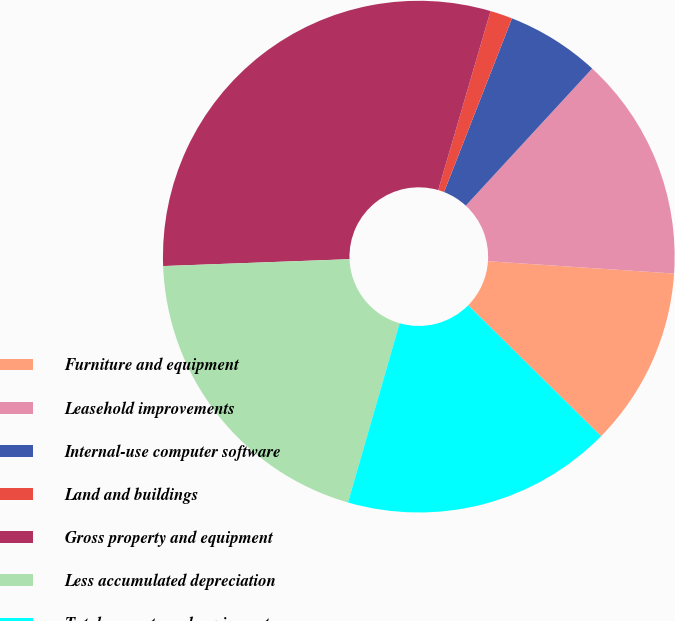<chart> <loc_0><loc_0><loc_500><loc_500><pie_chart><fcel>Furniture and equipment<fcel>Leasehold improvements<fcel>Internal-use computer software<fcel>Land and buildings<fcel>Gross property and equipment<fcel>Less accumulated depreciation<fcel>Total property and equipment<nl><fcel>11.33%<fcel>14.2%<fcel>5.92%<fcel>1.41%<fcel>30.11%<fcel>19.95%<fcel>17.08%<nl></chart> 